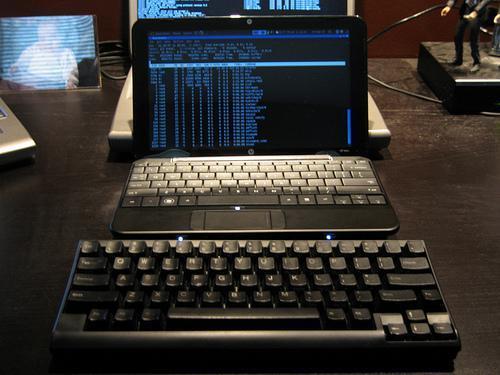How many keyboards can be seen?
Give a very brief answer. 2. 